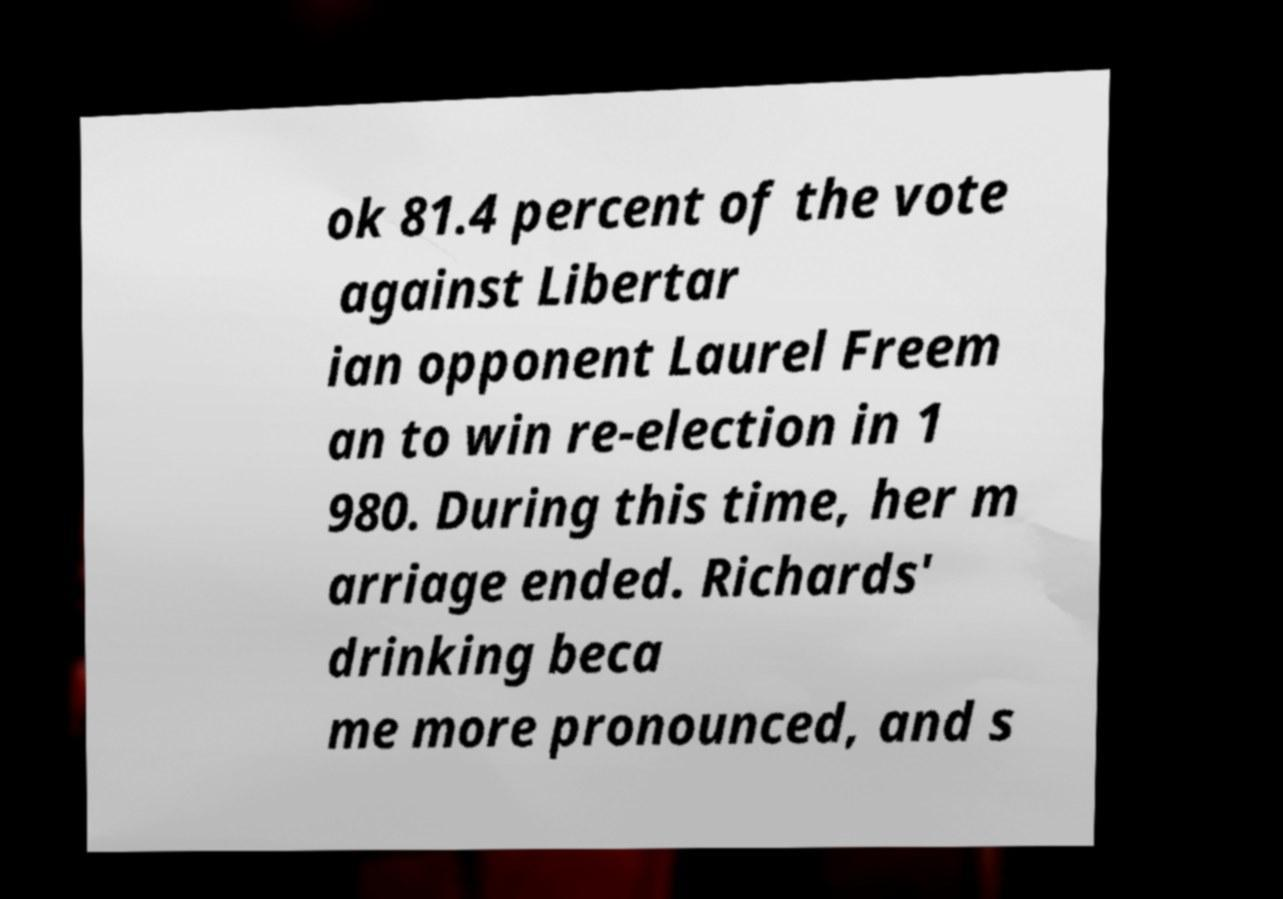Could you assist in decoding the text presented in this image and type it out clearly? ok 81.4 percent of the vote against Libertar ian opponent Laurel Freem an to win re-election in 1 980. During this time, her m arriage ended. Richards' drinking beca me more pronounced, and s 